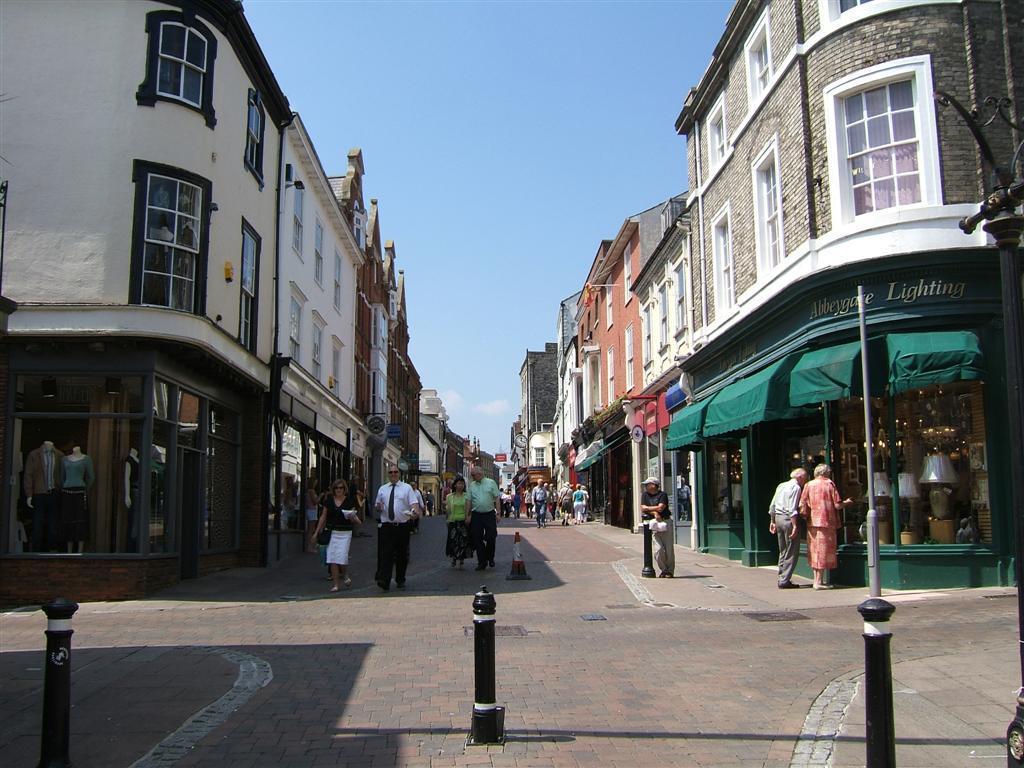How would you summarize this image in a sentence or two? At the bottom of the image on the floor there are poles. There are few people standing on the floor. And there are buildings with walls, windows, doors and glass windows. And also there are stores with roofs, glass doors and name boards. Inside the glass doors there few objects. At the top of the image there is sky. On the right side of the image there is a pole. 